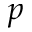<formula> <loc_0><loc_0><loc_500><loc_500>p</formula> 